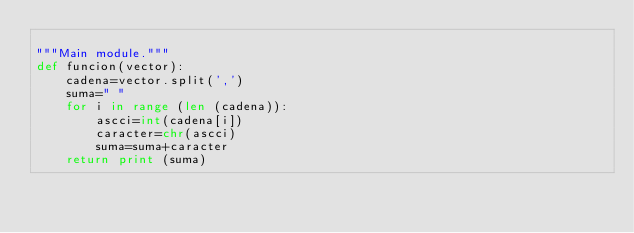<code> <loc_0><loc_0><loc_500><loc_500><_Python_>
"""Main module."""
def funcion(vector):
	cadena=vector.split(',')
	suma=" "
	for i in range (len (cadena)):
		ascci=int(cadena[i])
		caracter=chr(ascci)
		suma=suma+caracter
	return print (suma)
</code> 